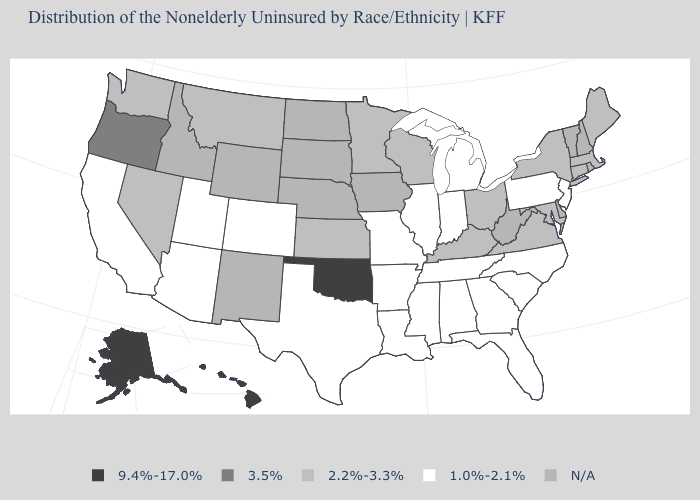Name the states that have a value in the range N/A?
Write a very short answer. Delaware, Idaho, Iowa, Nebraska, New Hampshire, New Mexico, North Dakota, Rhode Island, South Dakota, Vermont, West Virginia, Wyoming. Name the states that have a value in the range 9.4%-17.0%?
Be succinct. Alaska, Hawaii, Oklahoma. What is the value of West Virginia?
Answer briefly. N/A. Among the states that border Oregon , which have the highest value?
Quick response, please. Nevada, Washington. What is the highest value in the MidWest ?
Quick response, please. 2.2%-3.3%. Among the states that border Arkansas , does Louisiana have the lowest value?
Short answer required. Yes. Name the states that have a value in the range 9.4%-17.0%?
Give a very brief answer. Alaska, Hawaii, Oklahoma. What is the value of Kansas?
Quick response, please. 2.2%-3.3%. Among the states that border Nevada , which have the lowest value?
Give a very brief answer. Arizona, California, Utah. Which states hav the highest value in the Northeast?
Keep it brief. Connecticut, Maine, Massachusetts, New York. Name the states that have a value in the range 2.2%-3.3%?
Quick response, please. Connecticut, Kansas, Kentucky, Maine, Maryland, Massachusetts, Minnesota, Montana, Nevada, New York, Ohio, Virginia, Washington, Wisconsin. Among the states that border Iowa , which have the highest value?
Short answer required. Minnesota, Wisconsin. Among the states that border Virginia , which have the lowest value?
Give a very brief answer. North Carolina, Tennessee. Is the legend a continuous bar?
Short answer required. No. What is the value of North Dakota?
Quick response, please. N/A. 